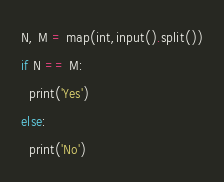<code> <loc_0><loc_0><loc_500><loc_500><_Python_>N, M = map(int,input().split())
if N == M:
  print('Yes')
else:
  print('No')</code> 